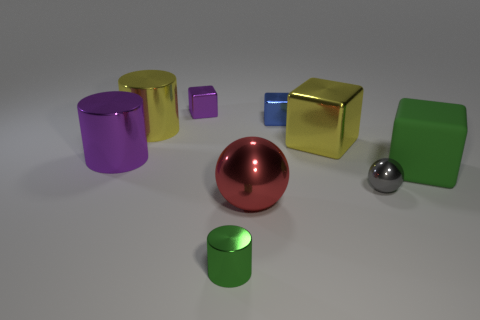There is a cylinder that is the same color as the large rubber thing; what size is it?
Your response must be concise. Small. What shape is the big yellow metal thing that is right of the tiny block that is to the right of the small metallic cylinder?
Your response must be concise. Cube. How big is the cube in front of the purple shiny thing that is in front of the yellow metallic cube?
Provide a short and direct response. Large. The small metal thing that is in front of the tiny gray metallic sphere is what color?
Your response must be concise. Green. There is a yellow cylinder that is made of the same material as the small gray sphere; what size is it?
Ensure brevity in your answer.  Large. How many other large green matte things have the same shape as the green matte thing?
Offer a terse response. 0. There is another block that is the same size as the purple shiny block; what is its material?
Give a very brief answer. Metal. Is there a yellow block made of the same material as the big green thing?
Ensure brevity in your answer.  No. The small object that is left of the yellow metal cube and in front of the big purple metal object is what color?
Provide a short and direct response. Green. How many other objects are the same color as the rubber block?
Your response must be concise. 1. 